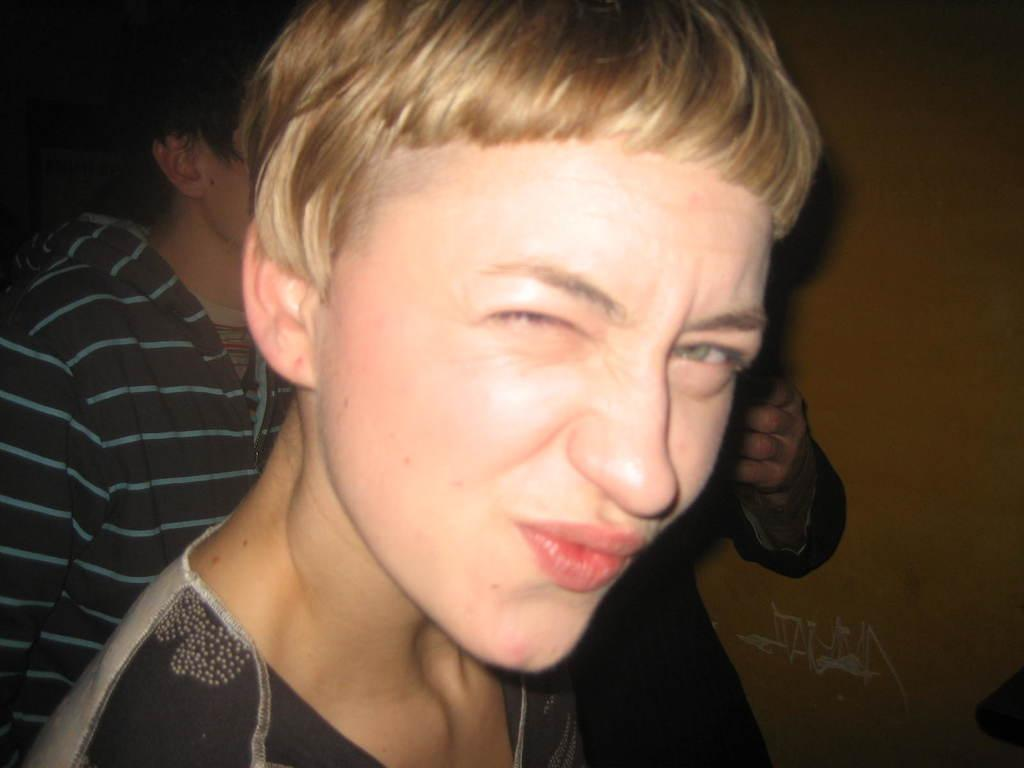Who is present in the image? There is a person in the image. What is the person wearing? The person is wearing a black T-shirt. What can be seen in the background of the image? There are people and a wall in the background of the image. What type of pest can be seen crawling on the stem of the plant in the image? There is no plant or stem present in the image, so it is not possible to determine if there are any pests. 